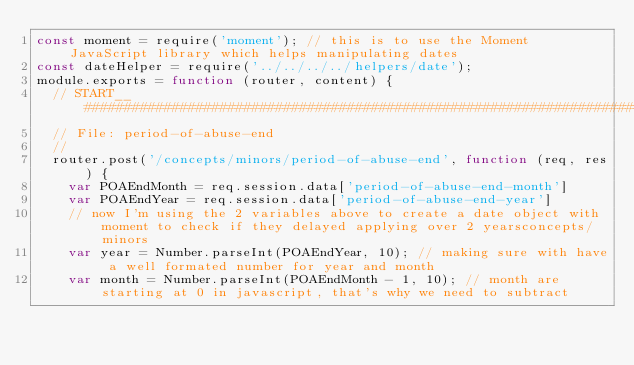<code> <loc_0><loc_0><loc_500><loc_500><_JavaScript_>const moment = require('moment'); // this is to use the Moment JavaScript library which helps manipulating dates
const dateHelper = require('../../../../helpers/date');
module.exports = function (router, content) {
  // START__####################################################################################################
  // File: period-of-abuse-end
  //
  router.post('/concepts/minors/period-of-abuse-end', function (req, res) {
    var POAEndMonth = req.session.data['period-of-abuse-end-month']
    var POAEndYear = req.session.data['period-of-abuse-end-year']
    // now I'm using the 2 variables above to create a date object with moment to check if they delayed applying over 2 yearsconcepts/minors
    var year = Number.parseInt(POAEndYear, 10); // making sure with have a well formated number for year and month
    var month = Number.parseInt(POAEndMonth - 1, 10); // month are starting at 0 in javascript, that's why we need to subtract</code> 